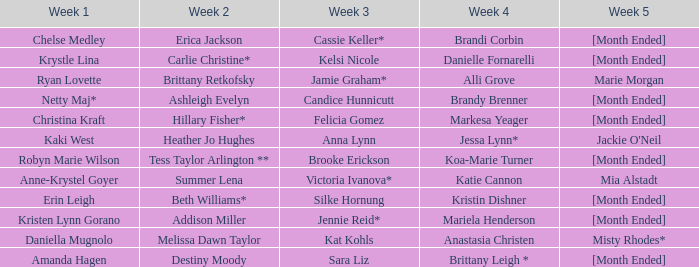What is the week 2 with daniella mugnolo in week 1? Melissa Dawn Taylor. 